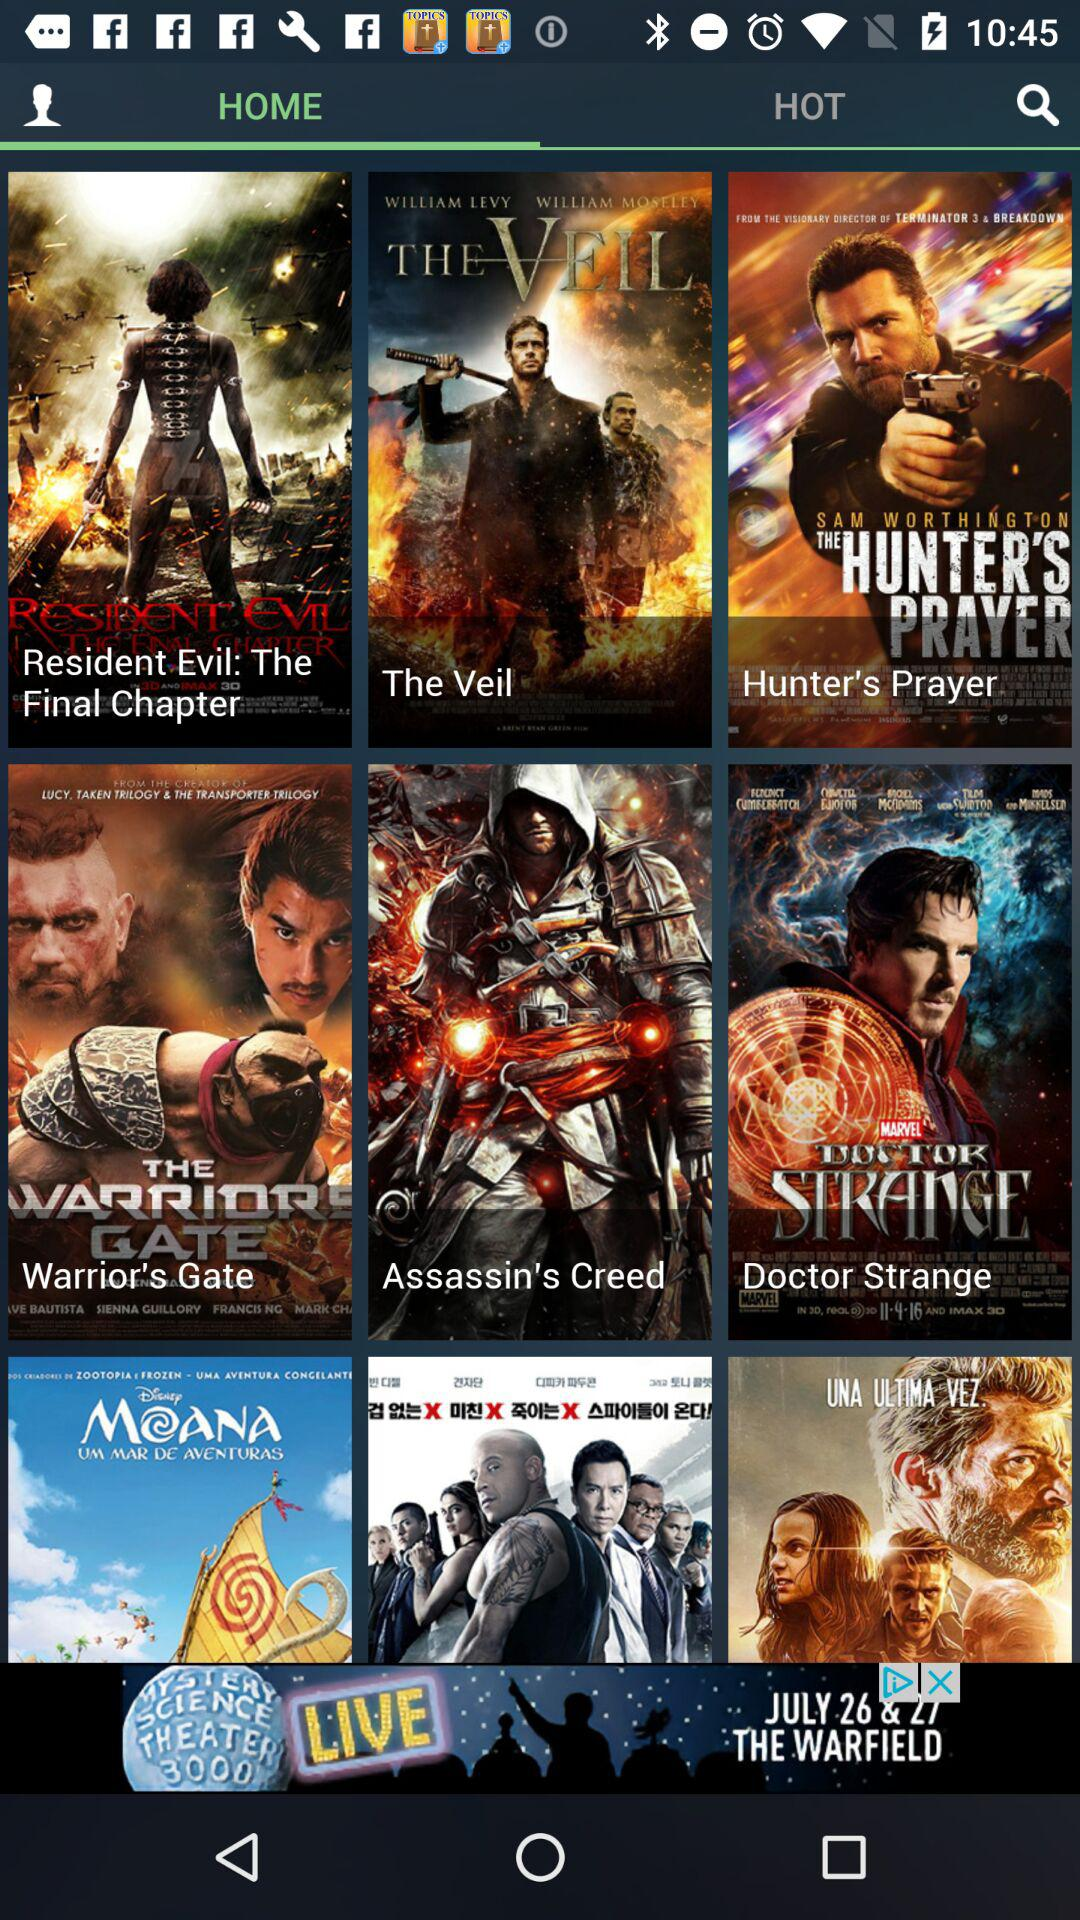Which tab is selected? The selected tab is "HOME". 